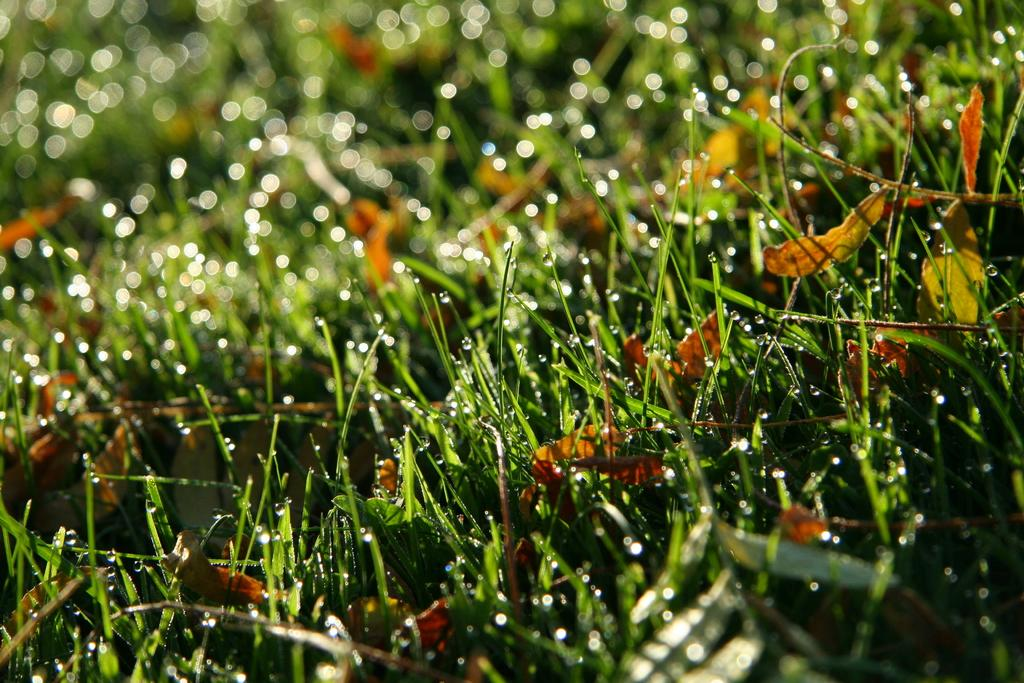What type of vegetation can be seen in the image? There is grass in the image. What is the condition of the grass? The grass has water drops on it. What else can be seen on the ground in the image? There are dried leaves in the image. Can you describe the background of the image? The background of the image is blurry. What brand of toothpaste is visible in the image? There is no toothpaste present in the image. How does the grass change color throughout the day in the image? The image does not show the grass changing color throughout the day; it only shows the grass with water drops on it. 